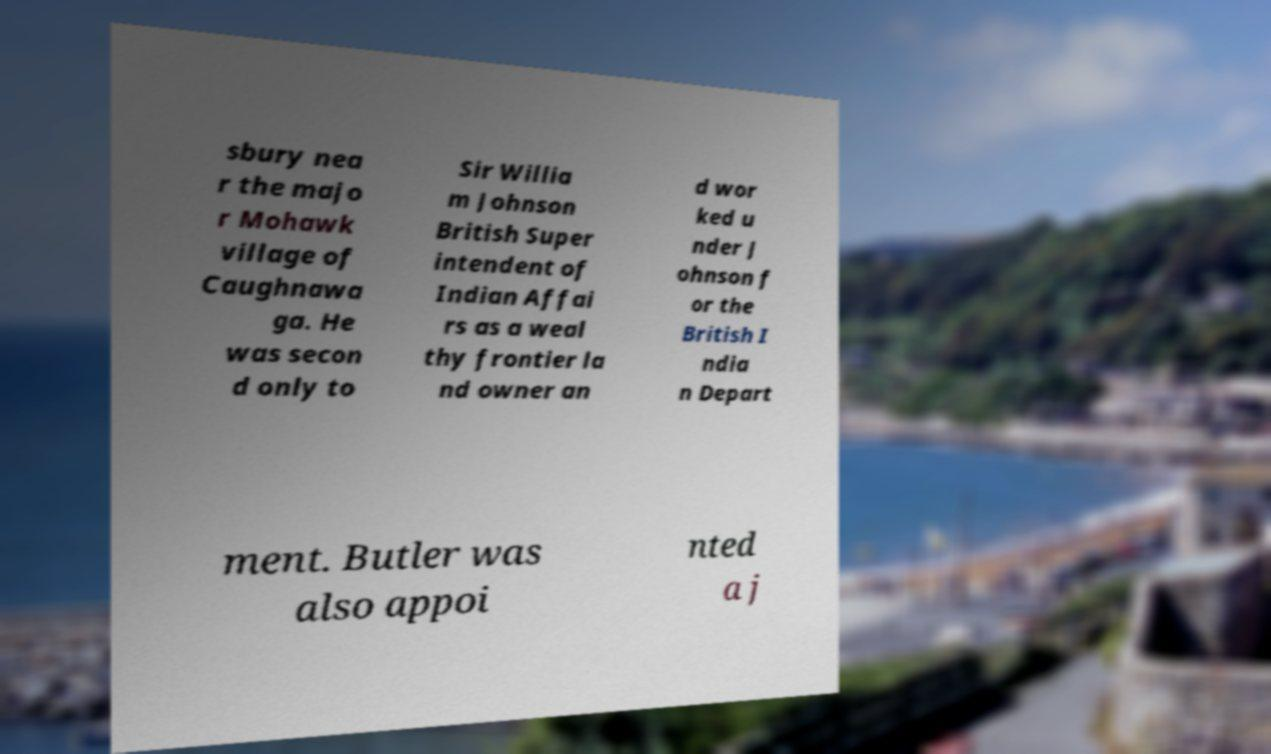Can you read and provide the text displayed in the image?This photo seems to have some interesting text. Can you extract and type it out for me? sbury nea r the majo r Mohawk village of Caughnawa ga. He was secon d only to Sir Willia m Johnson British Super intendent of Indian Affai rs as a weal thy frontier la nd owner an d wor ked u nder J ohnson f or the British I ndia n Depart ment. Butler was also appoi nted a j 